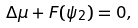Convert formula to latex. <formula><loc_0><loc_0><loc_500><loc_500>\Delta \mu + F ( \psi _ { 2 } ) = 0 ,</formula> 